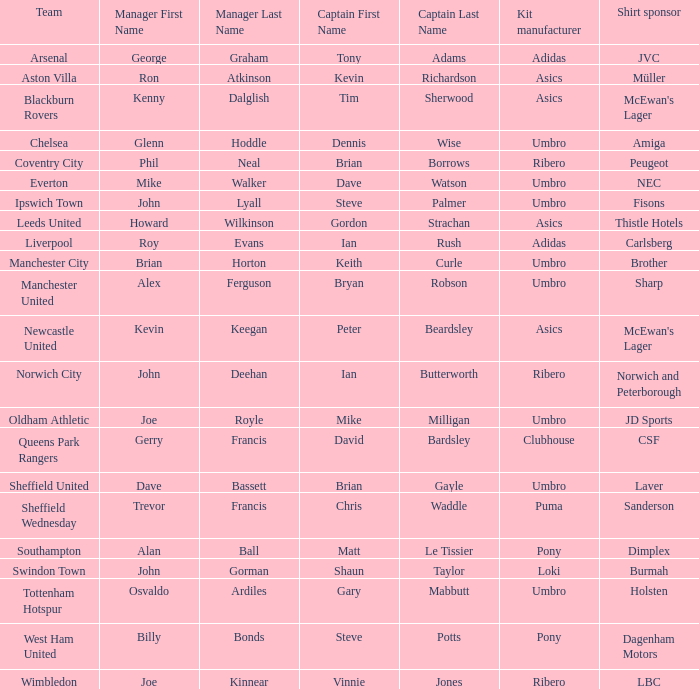Which manager has Manchester City as the team? Brian Horton. 